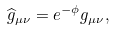<formula> <loc_0><loc_0><loc_500><loc_500>\widehat { g } _ { \mu \nu } = e ^ { - \phi } g _ { \mu \nu } ,</formula> 